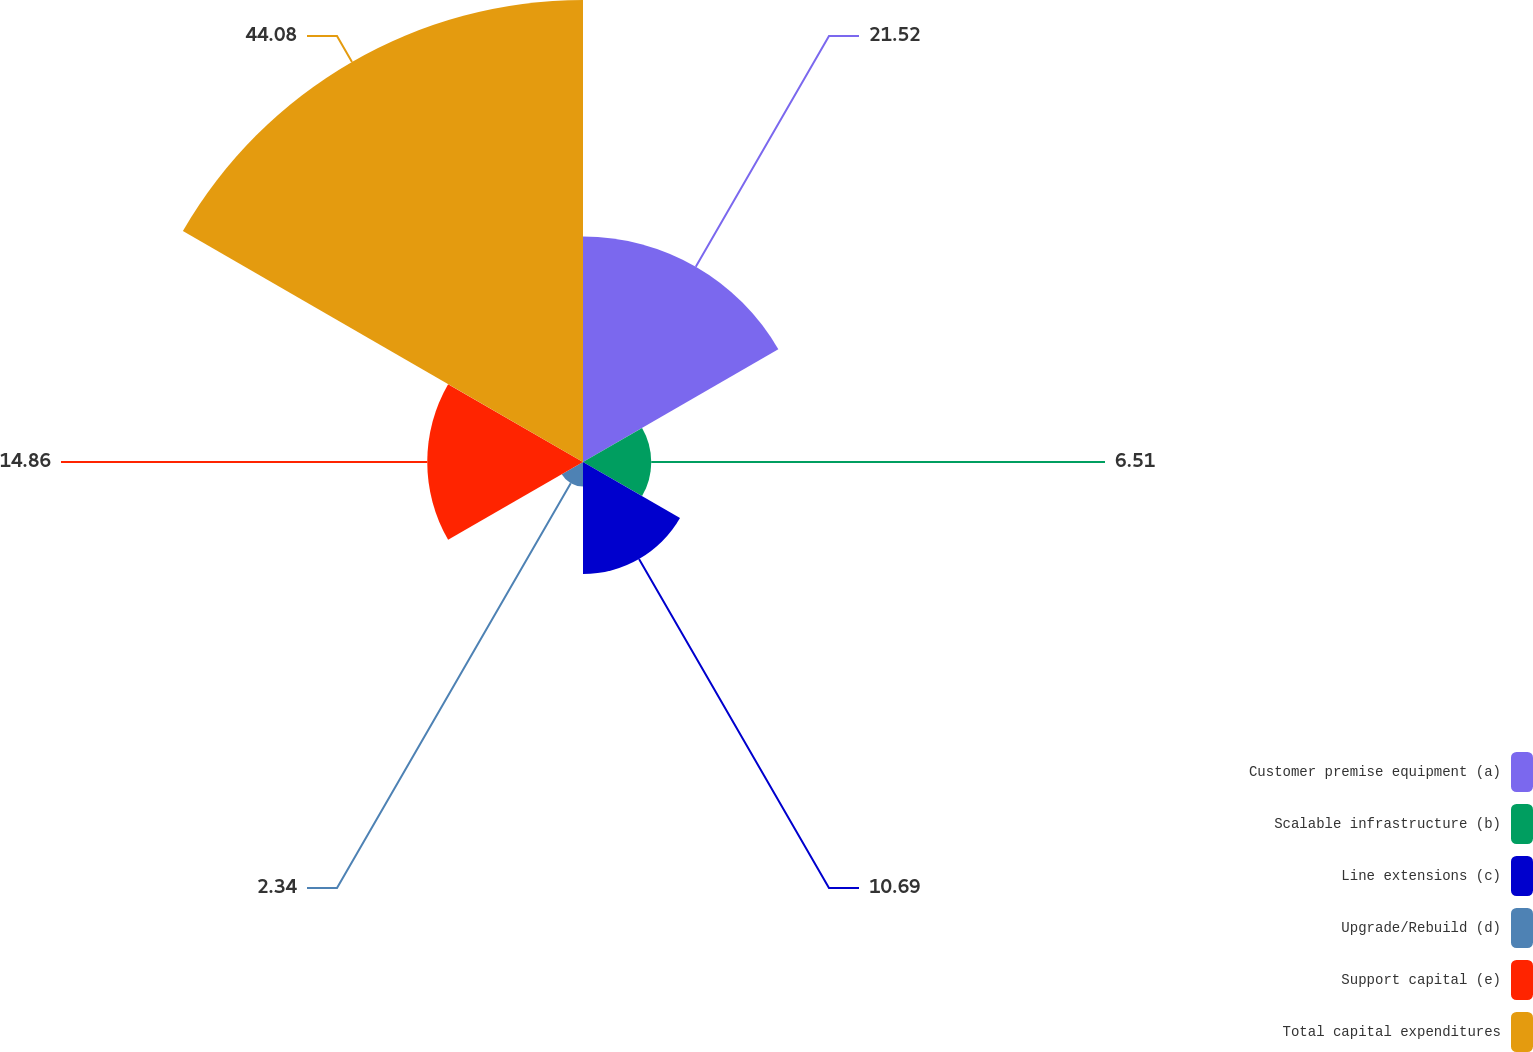Convert chart. <chart><loc_0><loc_0><loc_500><loc_500><pie_chart><fcel>Customer premise equipment (a)<fcel>Scalable infrastructure (b)<fcel>Line extensions (c)<fcel>Upgrade/Rebuild (d)<fcel>Support capital (e)<fcel>Total capital expenditures<nl><fcel>21.52%<fcel>6.51%<fcel>10.69%<fcel>2.34%<fcel>14.86%<fcel>44.08%<nl></chart> 